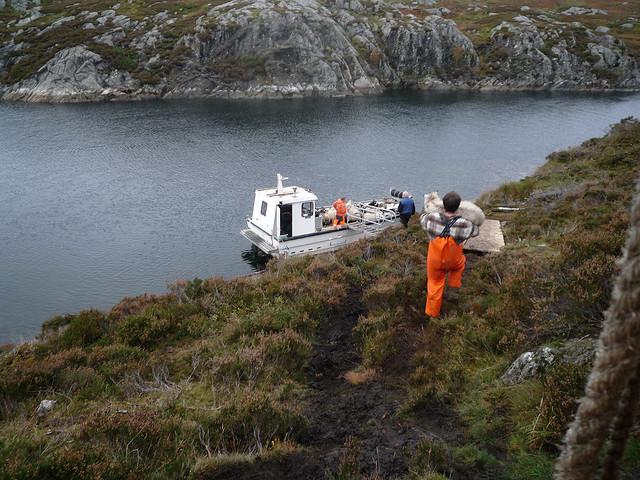Where is the boat?
Be succinct. In water. Is the man at the ocean?
Be succinct. Yes. What country are they in?
Answer briefly. Canada. What color overall is the man wearing?
Keep it brief. Orange. 